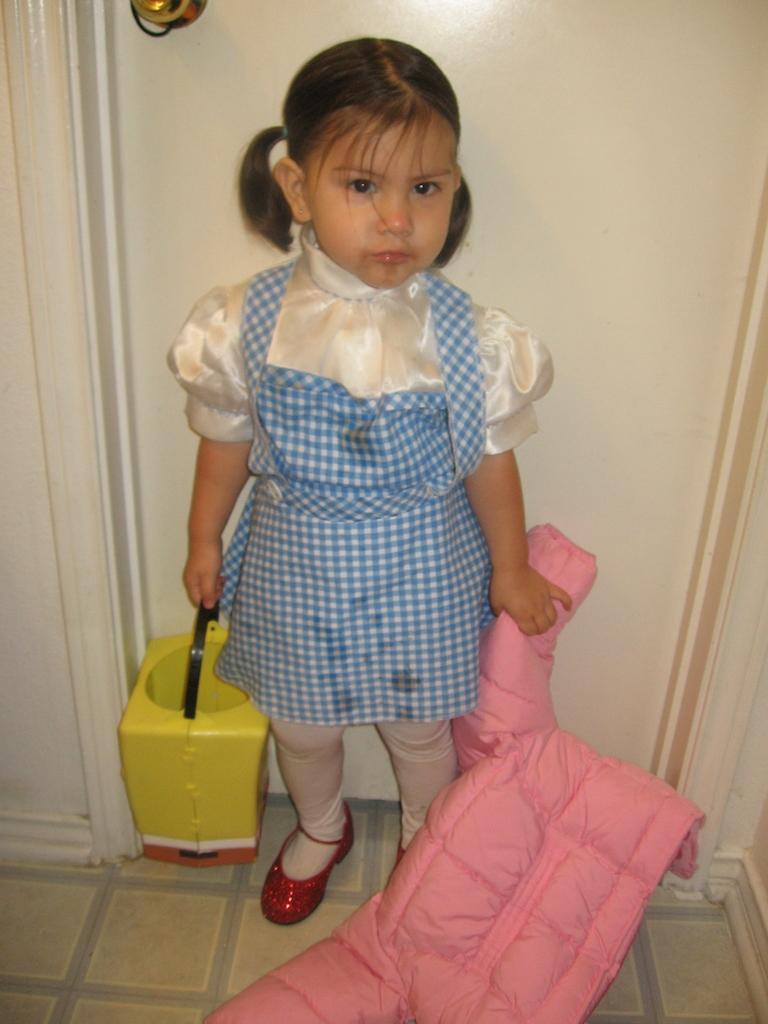How would you summarize this image in a sentence or two? In this image we can see a kid holding objects, in the background, we can see the wall. 